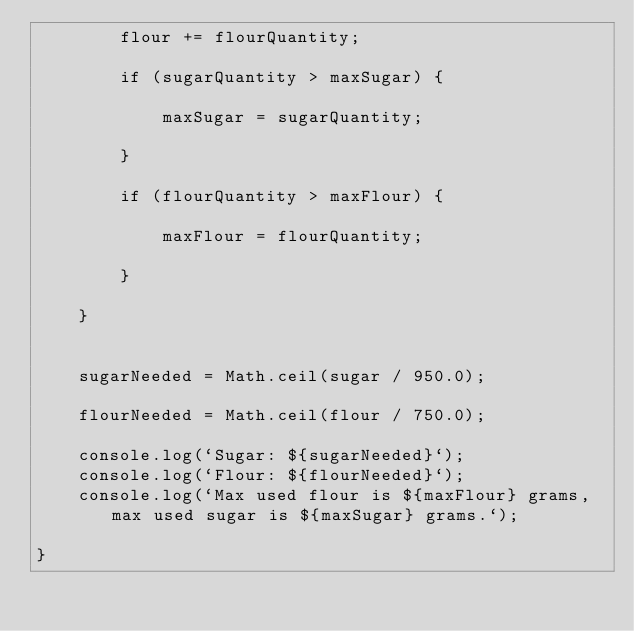<code> <loc_0><loc_0><loc_500><loc_500><_JavaScript_>        flour += flourQuantity;

        if (sugarQuantity > maxSugar) {

            maxSugar = sugarQuantity;

        }

        if (flourQuantity > maxFlour) {

            maxFlour = flourQuantity;

        }

    }


    sugarNeeded = Math.ceil(sugar / 950.0);

    flourNeeded = Math.ceil(flour / 750.0);

    console.log(`Sugar: ${sugarNeeded}`);
    console.log(`Flour: ${flourNeeded}`);
    console.log(`Max used flour is ${maxFlour} grams, max used sugar is ${maxSugar} grams.`);

}</code> 